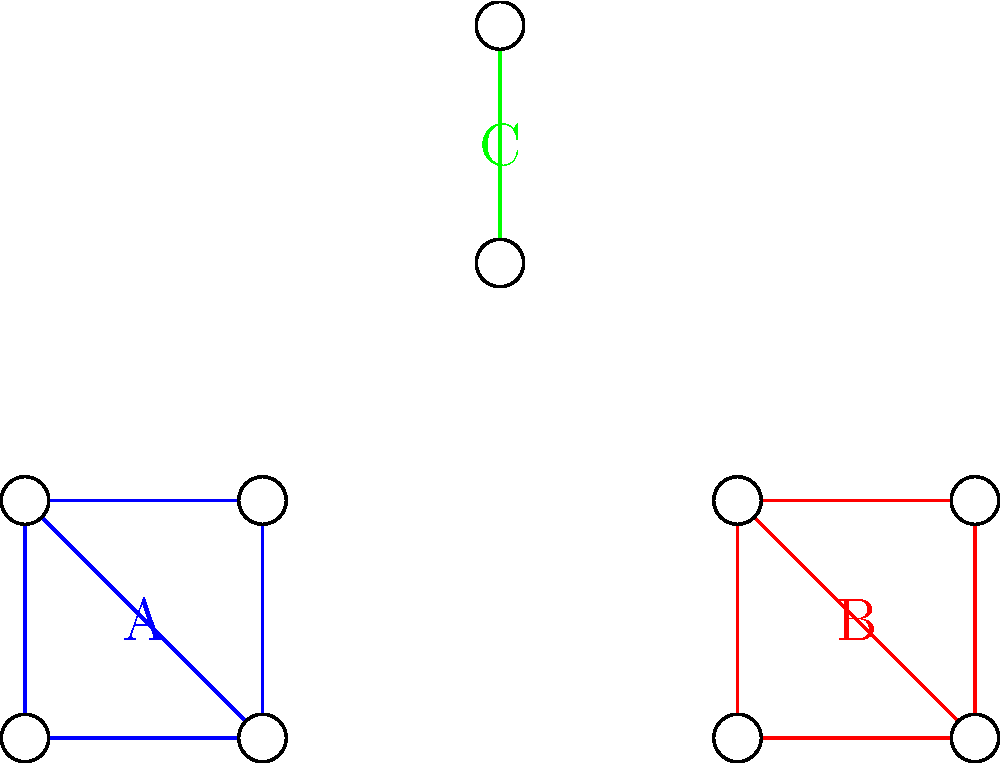In the network diagram above, three distinct communities are represented by different colors. How might these clusters metaphorically represent the various social circles in a podcaster's life, and what potential story could emerge from the interplay between these communities? To answer this question, let's break down the network diagram and its potential metaphorical meanings:

1. Cluster A (Blue): This tightly-knit group of four nodes could represent the podcaster's core team or closest collaborators. The strong connections between all nodes suggest frequent interaction and shared responsibilities.

2. Cluster B (Red): Another tightly-knit group of four nodes, possibly representing the podcaster's loyal listeners or fan community. The similar structure to Cluster A implies a strong, engaged audience.

3. Cluster C (Green): A smaller cluster of two nodes, potentially symbolizing the podcaster's personal life or family. The separation from the other clusters could indicate a work-life balance.

4. Positioning: Cluster C is positioned between Clusters A and B, suggesting that the podcaster's personal life might serve as a bridge between their work and audience.

5. Lack of direct connections between clusters: This could represent the challenges of maintaining boundaries between different aspects of the podcaster's life.

A potential story emerging from this network could be:

The podcaster struggles to balance their professional life (Cluster A) with the demands of an growing audience (Cluster B), while trying to maintain a separate personal life (Cluster C). As the podcast gains popularity, the lines between these social circles begin to blur, creating both opportunities and conflicts. The podcaster must navigate these interconnected communities, learning valuable lessons about authenticity, boundaries, and the power of storytelling to connect diverse groups of people.

This network structure invites reflection on how different aspects of our lives influence each other, even when they seem separate, and how storytelling can serve as a unifying force across various social circles.
Answer: Metaphor for podcaster's life balance and storytelling potential 